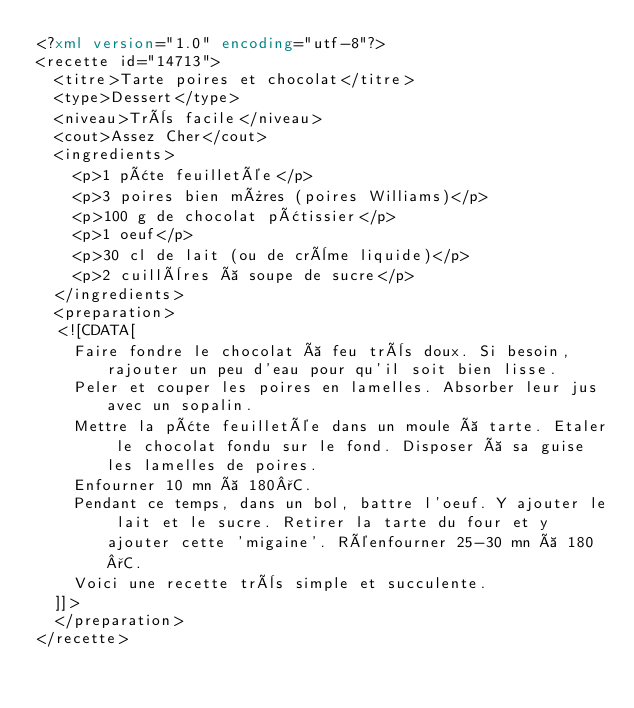Convert code to text. <code><loc_0><loc_0><loc_500><loc_500><_XML_><?xml version="1.0" encoding="utf-8"?>
<recette id="14713">
  <titre>Tarte poires et chocolat</titre>
  <type>Dessert</type>
  <niveau>Très facile</niveau>
  <cout>Assez Cher</cout>
  <ingredients>
    <p>1 pâte feuilletée</p>
    <p>3 poires bien mûres (poires Williams)</p>
    <p>100 g de chocolat pâtissier</p>
    <p>1 oeuf</p>
    <p>30 cl de lait (ou de crème liquide)</p>
    <p>2 cuillères à soupe de sucre</p>
  </ingredients>
  <preparation>
  <![CDATA[
    Faire fondre le chocolat à feu très doux. Si besoin, rajouter un peu d'eau pour qu'il soit bien lisse.
    Peler et couper les poires en lamelles. Absorber leur jus avec un sopalin.
    Mettre la pâte feuilletée dans un moule à tarte. Etaler le chocolat fondu sur le fond. Disposer à sa guise les lamelles de poires.
    Enfourner 10 mn à 180°C.
    Pendant ce temps, dans un bol, battre l'oeuf. Y ajouter le lait et le sucre. Retirer la tarte du four et y ajouter cette 'migaine'. Réenfourner 25-30 mn à 180°C.
    Voici une recette très simple et succulente.
  ]]>
  </preparation>
</recette>
</code> 